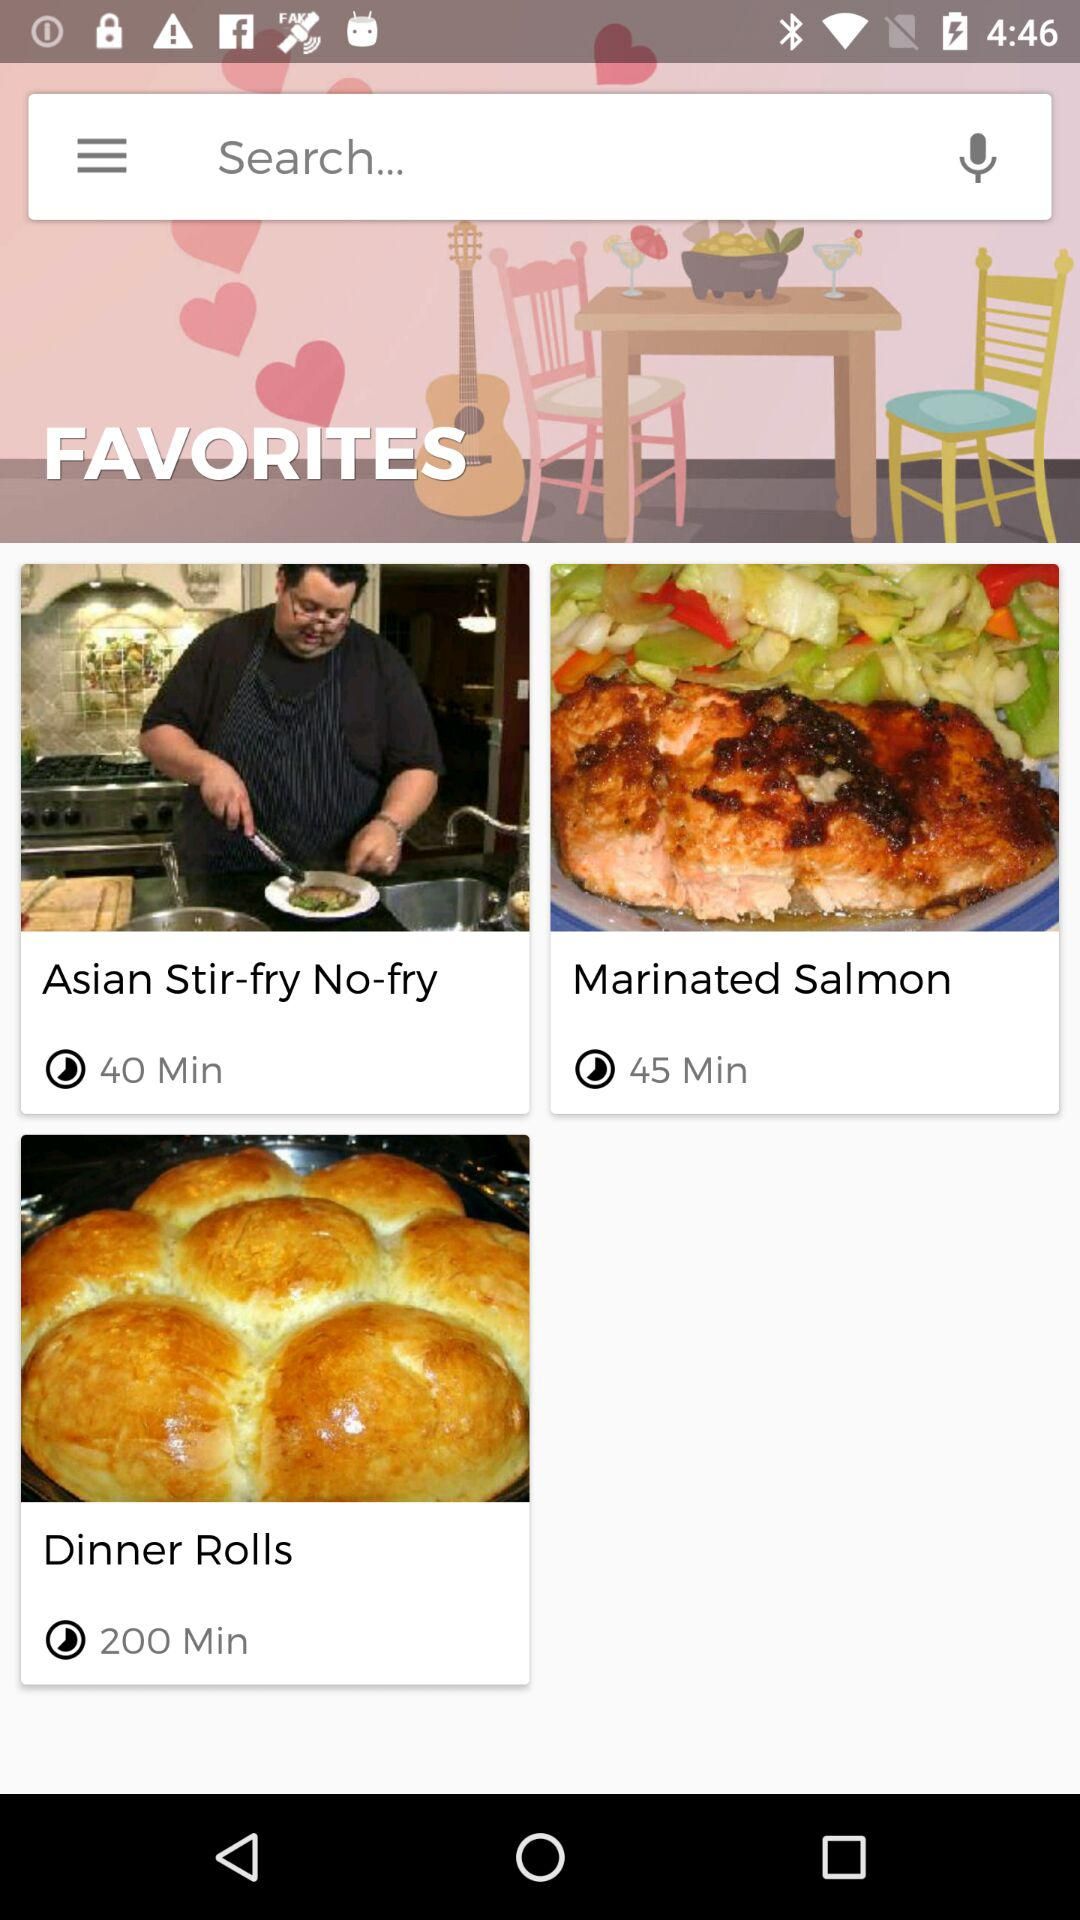What is the duration of the video "Asian Stir-fry No-fry"? The duration of the video "Asian Stir-fry No-fry" is 40 minutes. 